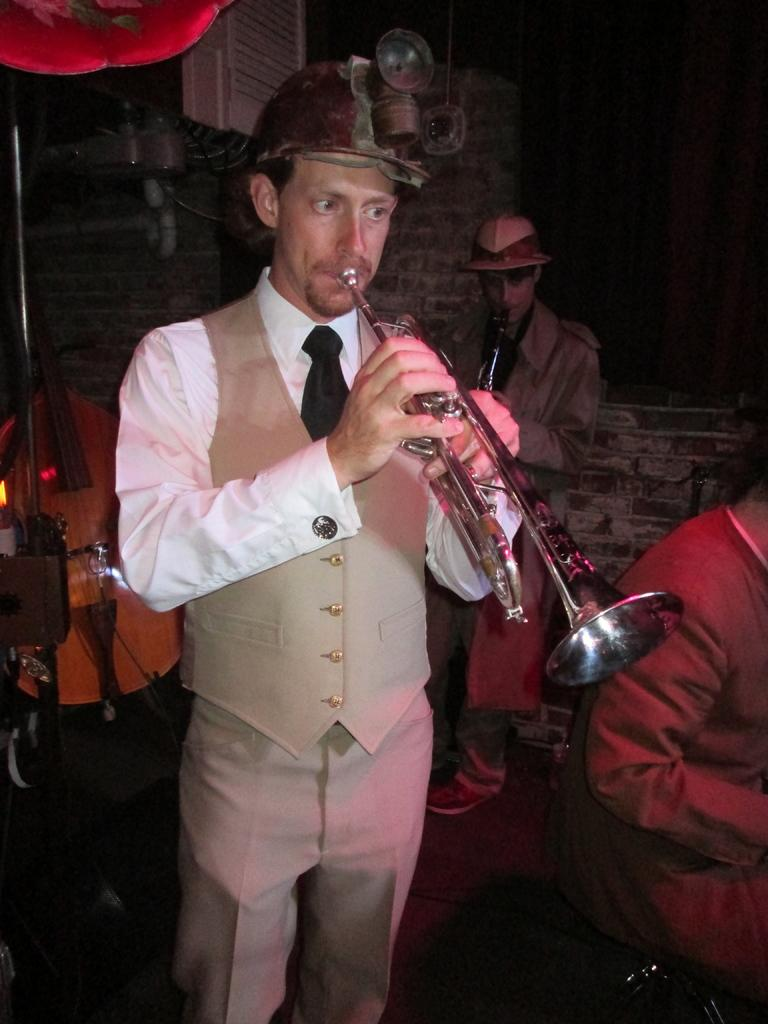What is the man in the image doing? The man is playing a musical instrument in the image. Can you describe the people behind the man? There are people behind the man, but their specific actions or features are not mentioned in the facts. What else can be seen in the image besides the man and the people behind him? There are musical instruments visible in the image. What type of silver twist can be seen in the man's hair in the image? There is no mention of the man's hair or any silver twist in the provided facts, so we cannot answer this question based on the image. 